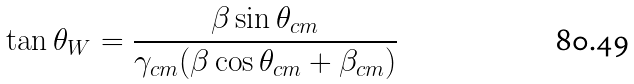<formula> <loc_0><loc_0><loc_500><loc_500>\tan { \theta _ { W } } = \frac { \beta \sin { \theta _ { c m } } } { \gamma _ { c m } ( \beta \cos { \theta _ { c m } } + \beta _ { c m } ) }</formula> 